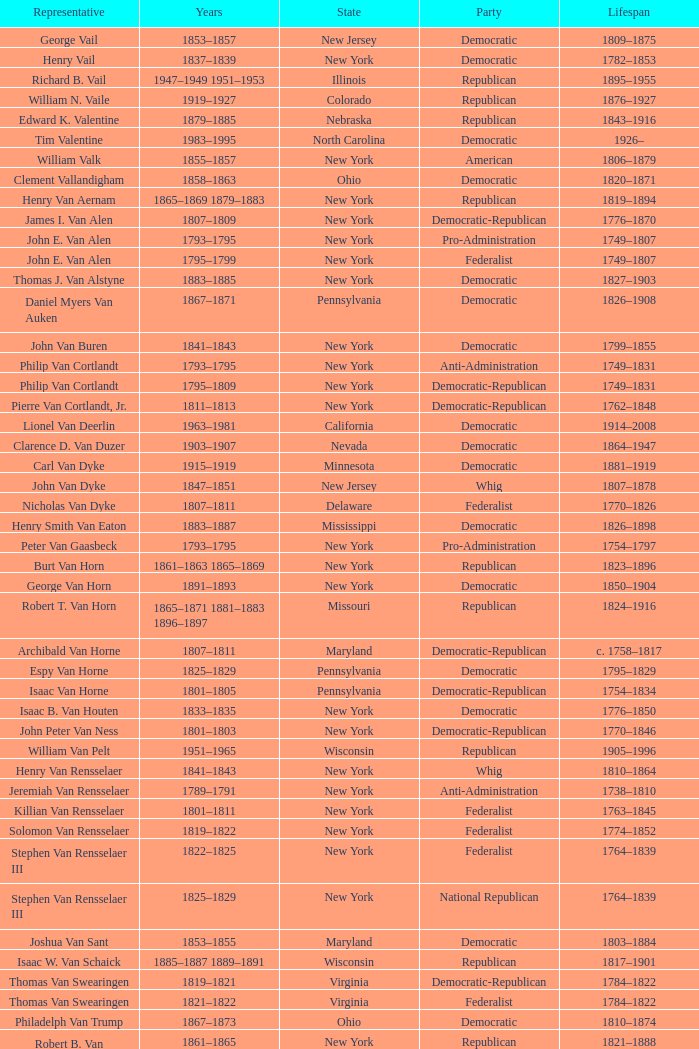What is the duration of joseph vance's life, a democratic-republican from ohio? 1786–1852. Help me parse the entirety of this table. {'header': ['Representative', 'Years', 'State', 'Party', 'Lifespan'], 'rows': [['George Vail', '1853–1857', 'New Jersey', 'Democratic', '1809–1875'], ['Henry Vail', '1837–1839', 'New York', 'Democratic', '1782–1853'], ['Richard B. Vail', '1947–1949 1951–1953', 'Illinois', 'Republican', '1895–1955'], ['William N. Vaile', '1919–1927', 'Colorado', 'Republican', '1876–1927'], ['Edward K. Valentine', '1879–1885', 'Nebraska', 'Republican', '1843–1916'], ['Tim Valentine', '1983–1995', 'North Carolina', 'Democratic', '1926–'], ['William Valk', '1855–1857', 'New York', 'American', '1806–1879'], ['Clement Vallandigham', '1858–1863', 'Ohio', 'Democratic', '1820–1871'], ['Henry Van Aernam', '1865–1869 1879–1883', 'New York', 'Republican', '1819–1894'], ['James I. Van Alen', '1807–1809', 'New York', 'Democratic-Republican', '1776–1870'], ['John E. Van Alen', '1793–1795', 'New York', 'Pro-Administration', '1749–1807'], ['John E. Van Alen', '1795–1799', 'New York', 'Federalist', '1749–1807'], ['Thomas J. Van Alstyne', '1883–1885', 'New York', 'Democratic', '1827–1903'], ['Daniel Myers Van Auken', '1867–1871', 'Pennsylvania', 'Democratic', '1826–1908'], ['John Van Buren', '1841–1843', 'New York', 'Democratic', '1799–1855'], ['Philip Van Cortlandt', '1793–1795', 'New York', 'Anti-Administration', '1749–1831'], ['Philip Van Cortlandt', '1795–1809', 'New York', 'Democratic-Republican', '1749–1831'], ['Pierre Van Cortlandt, Jr.', '1811–1813', 'New York', 'Democratic-Republican', '1762–1848'], ['Lionel Van Deerlin', '1963–1981', 'California', 'Democratic', '1914–2008'], ['Clarence D. Van Duzer', '1903–1907', 'Nevada', 'Democratic', '1864–1947'], ['Carl Van Dyke', '1915–1919', 'Minnesota', 'Democratic', '1881–1919'], ['John Van Dyke', '1847–1851', 'New Jersey', 'Whig', '1807–1878'], ['Nicholas Van Dyke', '1807–1811', 'Delaware', 'Federalist', '1770–1826'], ['Henry Smith Van Eaton', '1883–1887', 'Mississippi', 'Democratic', '1826–1898'], ['Peter Van Gaasbeck', '1793–1795', 'New York', 'Pro-Administration', '1754–1797'], ['Burt Van Horn', '1861–1863 1865–1869', 'New York', 'Republican', '1823–1896'], ['George Van Horn', '1891–1893', 'New York', 'Democratic', '1850–1904'], ['Robert T. Van Horn', '1865–1871 1881–1883 1896–1897', 'Missouri', 'Republican', '1824–1916'], ['Archibald Van Horne', '1807–1811', 'Maryland', 'Democratic-Republican', 'c. 1758–1817'], ['Espy Van Horne', '1825–1829', 'Pennsylvania', 'Democratic', '1795–1829'], ['Isaac Van Horne', '1801–1805', 'Pennsylvania', 'Democratic-Republican', '1754–1834'], ['Isaac B. Van Houten', '1833–1835', 'New York', 'Democratic', '1776–1850'], ['John Peter Van Ness', '1801–1803', 'New York', 'Democratic-Republican', '1770–1846'], ['William Van Pelt', '1951–1965', 'Wisconsin', 'Republican', '1905–1996'], ['Henry Van Rensselaer', '1841–1843', 'New York', 'Whig', '1810–1864'], ['Jeremiah Van Rensselaer', '1789–1791', 'New York', 'Anti-Administration', '1738–1810'], ['Killian Van Rensselaer', '1801–1811', 'New York', 'Federalist', '1763–1845'], ['Solomon Van Rensselaer', '1819–1822', 'New York', 'Federalist', '1774–1852'], ['Stephen Van Rensselaer III', '1822–1825', 'New York', 'Federalist', '1764–1839'], ['Stephen Van Rensselaer III', '1825–1829', 'New York', 'National Republican', '1764–1839'], ['Joshua Van Sant', '1853–1855', 'Maryland', 'Democratic', '1803–1884'], ['Isaac W. Van Schaick', '1885–1887 1889–1891', 'Wisconsin', 'Republican', '1817–1901'], ['Thomas Van Swearingen', '1819–1821', 'Virginia', 'Democratic-Republican', '1784–1822'], ['Thomas Van Swearingen', '1821–1822', 'Virginia', 'Federalist', '1784–1822'], ['Philadelph Van Trump', '1867–1873', 'Ohio', 'Democratic', '1810–1874'], ['Robert B. Van Valkenburg', '1861–1865', 'New York', 'Republican', '1821–1888'], ['H. Clay Van Voorhis', '1893–1905', 'Ohio', 'Republican', '1852–1927'], ['John Van Voorhis', '1879–1883 1893–1895', 'New York', 'Republican', '1826–1905'], ['Nelson H. Van Vorhes', '1875–1879', 'Ohio', 'Republican', '1822–1882'], ['Marshall Van Winkle', '1905–1907', 'New Jersey', 'Republican', '1869–1957'], ['Charles Van Wyck', '1859–1863 1867–1869 1870–1871', 'New York', 'Republican', '1824–1895'], ['William W. Van Wyck', '1821–1825', 'New York', 'Democratic-Republican', '1777–1840'], ['James E. Van Zandt', '1939–1943 1947–1963', 'Pennsylvania', 'Republican', '1898–1986'], ['John L. Vance', '1875–1877', 'Ohio', 'Democratic', '1839–1921'], ['Joseph Vance', '1821–1825', 'Ohio', 'Democratic-Republican', '1786–1852'], ['Joseph Vance', '1825–1835', 'Ohio', 'National Republican', '1786–1852'], ['Joseph Vance', '1843–1847', 'Ohio', 'Whig', '1786–1852'], ['Robert B. Vance', '1873–1885', 'North Carolina', 'Democratic', '1828–1899'], ['Robert Brank Vance', '1823–1825', 'North Carolina', 'Democratic-Republican', '1793–1827'], ['Robert J. Vance', '1887–1889', 'Connecticut', 'Democratic', '1854–1902'], ['Zebulon Baird Vance', '1858–1861', 'North Carolina', 'Democratic', '1830–1894'], ['Guy Vander Jagt', '1966–1993', 'Michigan', 'Republican', '1931–2007'], ['Richard VanderVeen', '1974–1977', 'Michigan', 'Democratic', '1922–2006'], ['Tom Vandergriff', '1983–1985', 'Texas', 'Democratic', '1926–2010'], ['Aaron Vanderpoel', '1833–1837 1839–1841', 'New York', 'Democratic', '1799–1870'], ['Abraham Vanderveer', '1837–1839', 'New York', 'Democratic', '1781–1839'], ['William Vandever', '1859–1861', 'Iowa', 'Republican', '1817–1893'], ['William Vandever', '1887–1891', 'California', 'Republican', '1817–1893'], ['Willard Duncan Vandiver', '1897–1905', 'Missouri', 'Democratic', '1854–1932'], ['Charles Vanik', '1955–1981', 'Ohio', 'Democratic', '1913–2007'], ['John I. Vanmeter', '1843–1845', 'Ohio', 'Whig', '1798–1875'], ['William S. Vare', '1912–1923 1923–1927', 'Pennsylvania', 'Republican', '1867–1934'], ['John Varnum', '1825–1831', 'Massachusetts', 'National Republican', '1778–1836'], ['Joseph Bradley Varnum', '1795–1811', 'Massachusetts', 'Democratic-Republican', '1750/51-1821'], ['Horace Worth Vaughan', '1913–1915', 'Texas', 'Democratic', '1867–1922'], ['William Wirt Vaughan', '1871–1873', 'Tennessee', 'Democratic', '1831–1878'], ['Albert C. Vaughn', '1951', 'Pennsylvania', 'Republican', '1894–1951'], ['Richard Vaux', '1890–1891', 'Pennsylvania', 'Democratic', '1816–1895'], ['William D. Veeder', '1877–1879', 'New York', 'Democratic', '1835–1910'], ['John H. G. Vehslage', '1897–1899', 'New York', 'Democratic', '1842–1904'], ['Harold Himmel Velde', '1949–1957', 'Illinois', 'Republican', '1910–1985'], ['Abraham B. Venable', '1791–1795', 'Virginia', 'Anti-Administration', '1758–1811'], ['Abraham B. Venable', '1795–1799', 'Virginia', 'Democratic-Republican', '1758–1811'], ['Abraham Watkins Venable', '1847–1853', 'North Carolina', 'Democratic', '1799–1876'], ['Edward Carrington Venable', '1889–1890', 'Virginia', 'Democratic', '1853–1908'], ['William W. Venable', '1916–1921', 'Mississippi', 'Democratic', '1880–1948'], ['Bruce Vento', '1977–2000', 'Minnesota', 'Democratic-Farmer-Labor', '1940–2000'], ['Daniel C. Verplanck', '1803–1809', 'New York', 'Democratic-Republican', '1762–1834'], ['Gulian Crommelin Verplanck', '1825–1833', 'New York', 'Democratic', '1786–1870'], ['John Paul Verree', '1859–1863', 'Pennsylvania', 'Republican', '1817–1889'], ['Albert Henry Vestal', '1917–1932', 'Indiana', 'Republican', '1875–1932'], ['Victor Veysey', '1971–1975', 'California', 'Republican', '1915–2001'], ['Chauncey Vibbard', '1861–1863', 'New York', 'Democratic', '1811–1891'], ['Michel Vidal', '1868–1869', 'Louisiana', 'Republican', '1824-1???'], ['Egbert Ludovicus Viele', '1885–1887', 'New York', 'Democratic', '1825–1902'], ['Joseph P. Vigorito', '1965–1977', 'Pennsylvania', 'Democratic', '1918–2003'], ['Beverly M. Vincent', '1937–1945', 'Kentucky', 'Democratic', '1890–1980'], ['Bird J. Vincent', '1923–1931', 'Michigan', 'Republican', '1880–1931'], ['Earl W. Vincent', '1928–1929', 'Iowa', 'Republican', '1886–1953'], ['William D. Vincent', '1897–1899', 'Kansas', 'Populist', '1852–1922'], ['John M. Vining', '1789–1793', 'Delaware', 'Pro-Administration', '1758–1802'], ['Carl Vinson', '1915–1965', 'Georgia', 'Democratic', '1883–1981'], ['Fred M. Vinson', '1924–1929 1931–1938', 'Kentucky', 'Democratic', '1890–1953'], ['Samuel Finley Vinton', '1823–1825', 'Ohio', 'Democratic-Republican', '1792–1862'], ['Samuel Finley Vinton', '1825–1835', 'Ohio', 'National Republican', '1792–1862'], ['Samuel Finley Vinton', '1835–1837 1843–1851', 'Ohio', 'Whig', '1792–1862'], ['David Vitter', '1999–2005', 'Louisiana', 'Republican', '1961–'], ['Weston E. Vivian', '1965–1967', 'Michigan', 'Democratic', '1924–'], ['Edward Voigt', '1917–1927', 'Wisconsin', 'Republican', '1873–1934'], ['Lester D. Volk', '1920–1923', 'New York', 'Republican', '1884–1962'], ['Harold Volkmer', '1977–1997', 'Missouri', 'Democratic', '1931–2011'], ['Henry Vollmer', '1914–1915', 'Iowa', 'Democratic', '1867–1930'], ['Andrew Volstead', '1903–1923', 'Minnesota', 'Republican', '1860–1947'], ['Daniel W. Voorhees', '1861–1866 1869–1873', 'Indiana', 'Democratic', '1827–1897'], ['Charles H. Voorhis', '1879–1881', 'New Jersey', 'Republican', '1833–1896'], ['Jerry Voorhis', '1937–1947', 'California', 'Democratic', '1901–1984'], ['John M. Vorys', '1939–1959', 'Ohio', 'Republican', '1896–1968'], ['Roger Vose', '1813–1817', 'New Hampshire', 'Federalist', '1763–1841'], ['Albert L. Vreeland', '1939–1943', 'New Jersey', 'Republican', '1901–1975'], ['Edward B. Vreeland', '1899–1913', 'New York', 'Republican', '1856–1936'], ['Peter Dumont Vroom', '1839–1841', 'New Jersey', 'Democratic', '1791–1873'], ['Barbara Vucanovich', '1983–1997', 'Nevada', 'Republican', '1921–2013'], ['Charles W. Vursell', '1943–1959', 'Illinois', 'Republican', '1881–1974']]} 